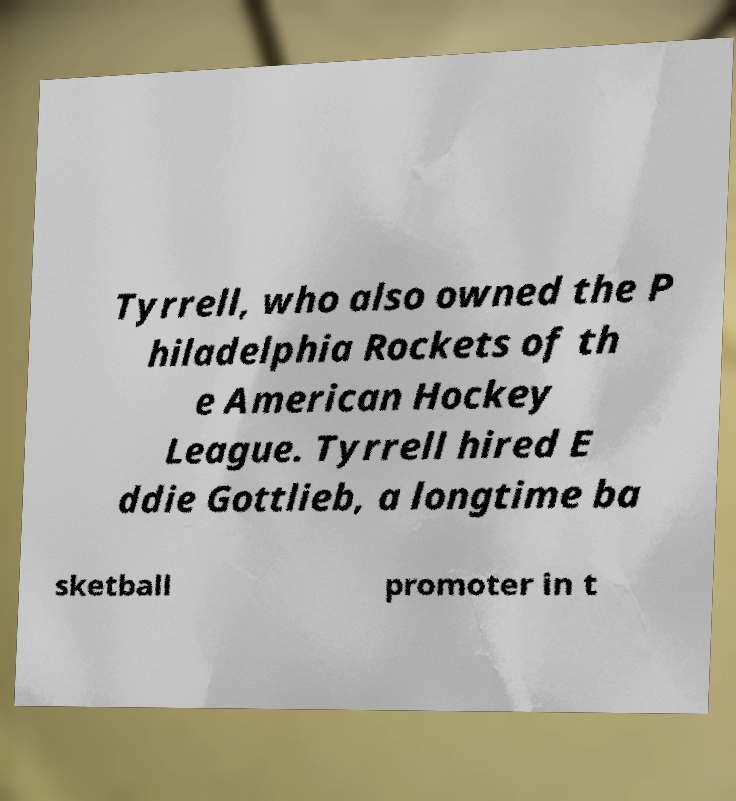Please read and relay the text visible in this image. What does it say? Tyrrell, who also owned the P hiladelphia Rockets of th e American Hockey League. Tyrrell hired E ddie Gottlieb, a longtime ba sketball promoter in t 